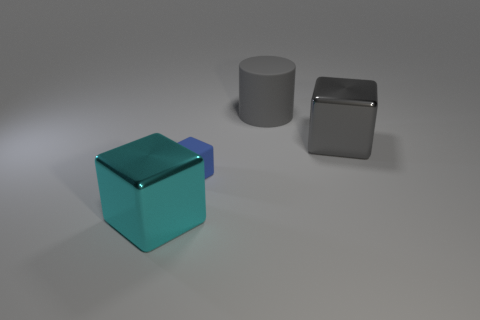Subtract all metal cubes. How many cubes are left? 1 Add 3 large cyan blocks. How many objects exist? 7 Subtract all blue blocks. How many blocks are left? 2 Subtract all cylinders. How many objects are left? 3 Subtract 1 cubes. How many cubes are left? 2 Subtract all gray balls. How many gray cubes are left? 1 Subtract all big cyan shiny cubes. Subtract all large rubber cylinders. How many objects are left? 2 Add 1 large cylinders. How many large cylinders are left? 2 Add 1 small cyan matte spheres. How many small cyan matte spheres exist? 1 Subtract 0 green cubes. How many objects are left? 4 